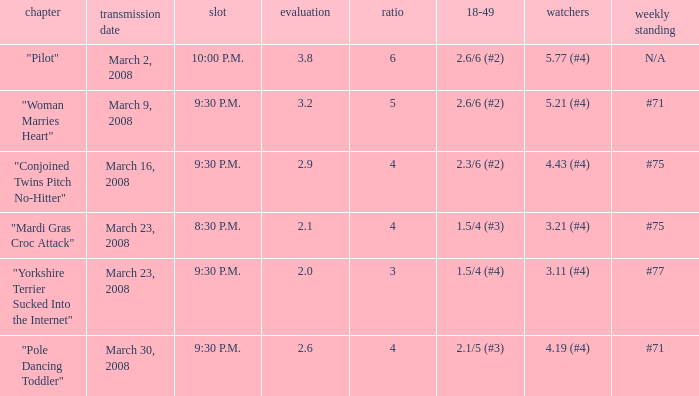What is the total ratings on share less than 4? 1.0. 